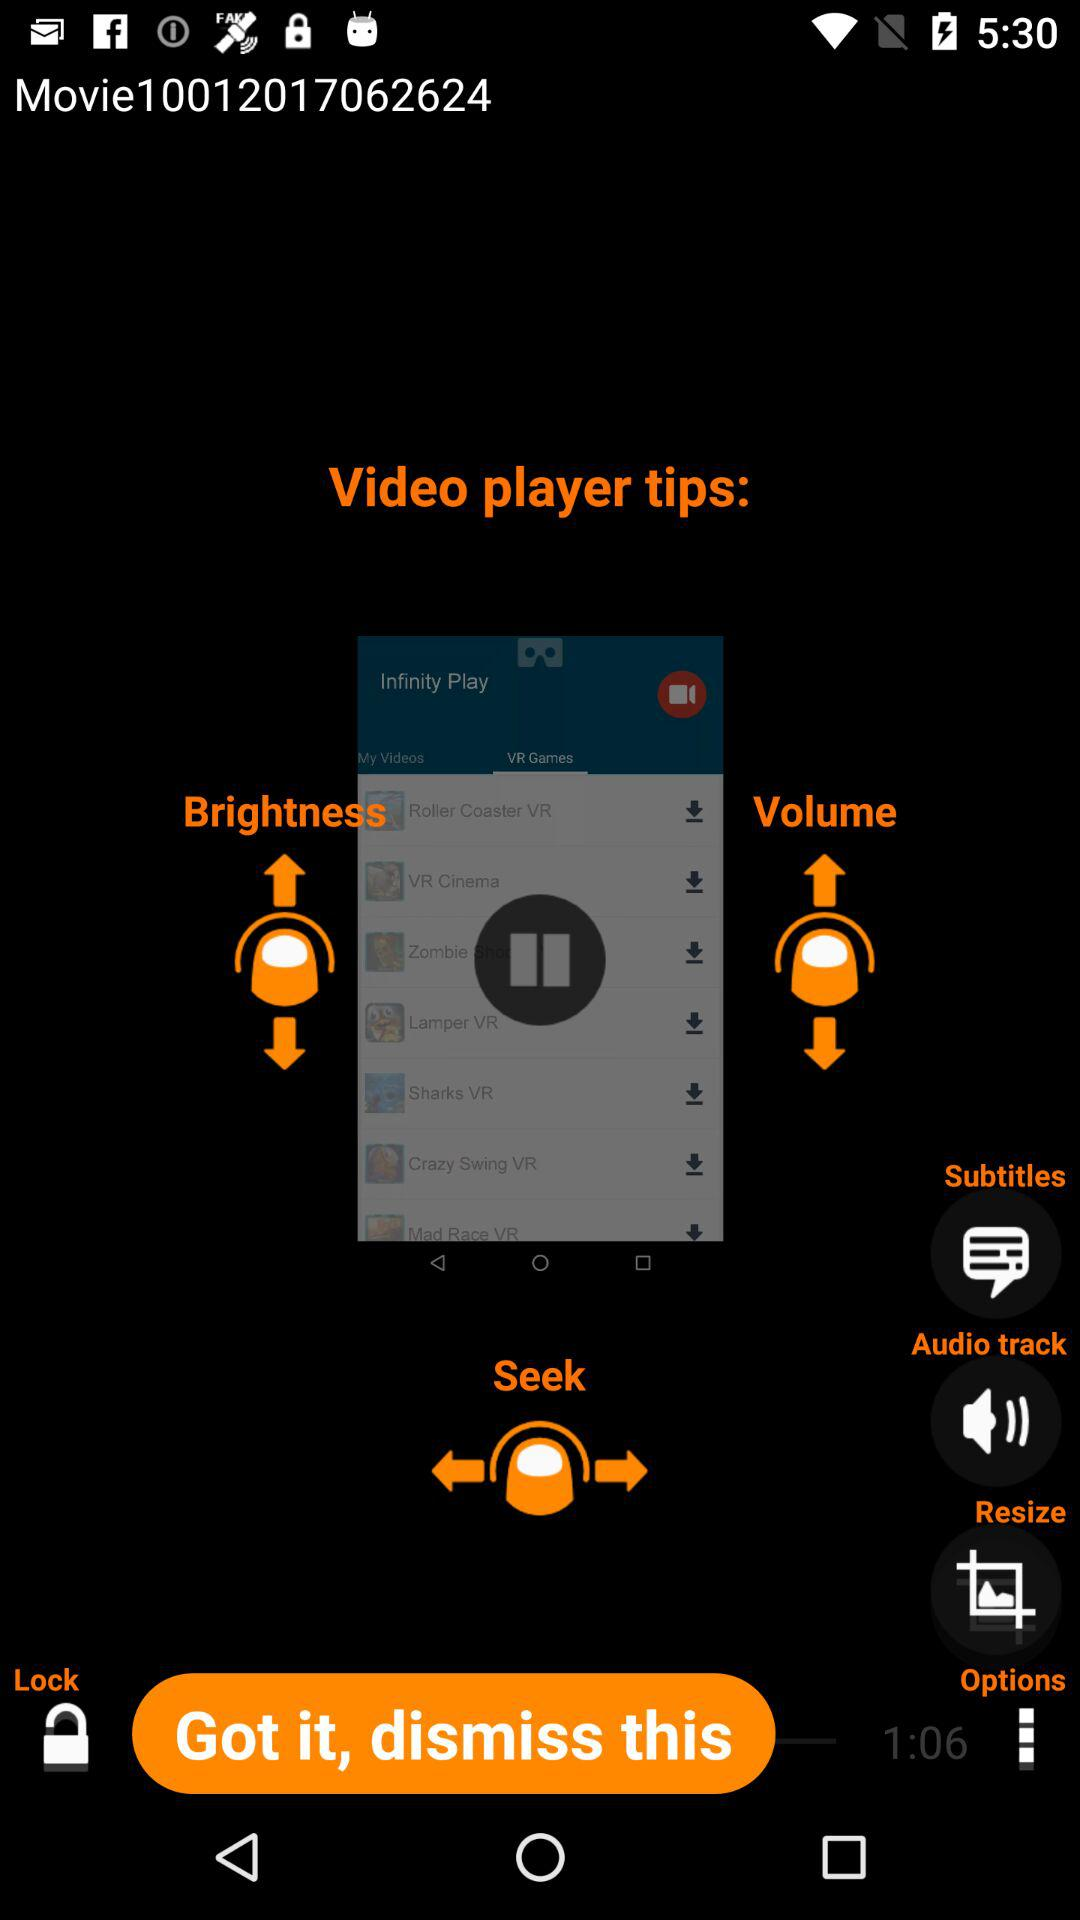What are the given options? The given options are "Subtitles", "Audio track", "Resize", "Options" and "Lock". 